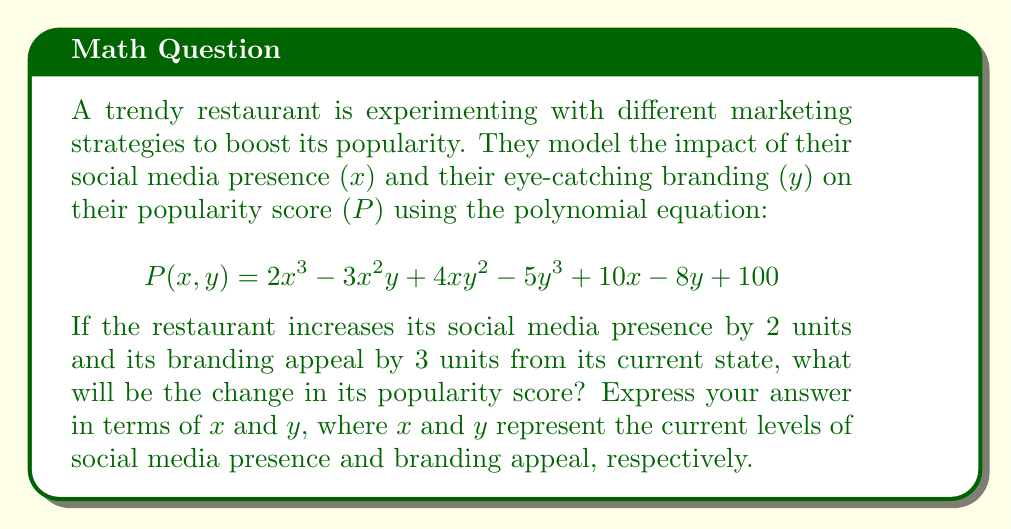Provide a solution to this math problem. To solve this problem, we need to follow these steps:

1) First, let's define the new popularity function after the increases:
   $$P_{new}(x,y) = P(x+2, y+3)$$

2) Now, we need to expand this function:
   $$P_{new}(x,y) = 2(x+2)^3 - 3(x+2)^2(y+3) + 4(x+2)(y+3)^2 - 5(y+3)^3 + 10(x+2) - 8(y+3) + 100$$

3) Let's expand each term:
   - $2(x+2)^3 = 2(x^3 + 6x^2 + 12x + 8) = 2x^3 + 12x^2 + 24x + 16$
   - $-3(x+2)^2(y+3) = -3(x^2 + 4x + 4)(y+3) = -3x^2y - 9x^2 - 12xy - 36x - 12y - 36$
   - $4(x+2)(y+3)^2 = 4(x+2)(y^2 + 6y + 9) = 4xy^2 + 24xy + 36x + 8y^2 + 48y + 72$
   - $-5(y+3)^3 = -5(y^3 + 9y^2 + 27y + 27) = -5y^3 - 45y^2 - 135y - 135$
   - $10(x+2) = 10x + 20$
   - $-8(y+3) = -8y - 24$

4) Now, let's combine like terms:
   $$P_{new}(x,y) = 2x^3 + 12x^2 + 24x + 16 - 3x^2y - 9x^2 - 12xy - 36x - 12y - 36 + 4xy^2 + 24xy + 36x + 8y^2 + 48y + 72 - 5y^3 - 45y^2 - 135y - 135 + 10x + 20 - 8y - 24$$

5) Simplifying:
   $$P_{new}(x,y) = 2x^3 + 3x^2 - 3x^2y + 4xy^2 + 12xy + 34x - 5y^3 - 37y^2 - 107y + 13$$

6) To find the change in popularity, we need to subtract the original function from the new function:
   $$\Delta P = P_{new}(x,y) - P(x,y)$$
   $$= (2x^3 + 3x^2 - 3x^2y + 4xy^2 + 12xy + 34x - 5y^3 - 37y^2 - 107y + 13) - (2x^3 - 3x^2y + 4xy^2 - 5y^3 + 10x - 8y + 100)$$

7) Simplifying:
   $$\Delta P = 3x^2 + 12xy + 24x - 37y^2 - 99y - 87$$

This polynomial represents the change in popularity score.
Answer: $$\Delta P = 3x^2 + 12xy + 24x - 37y^2 - 99y - 87$$ 